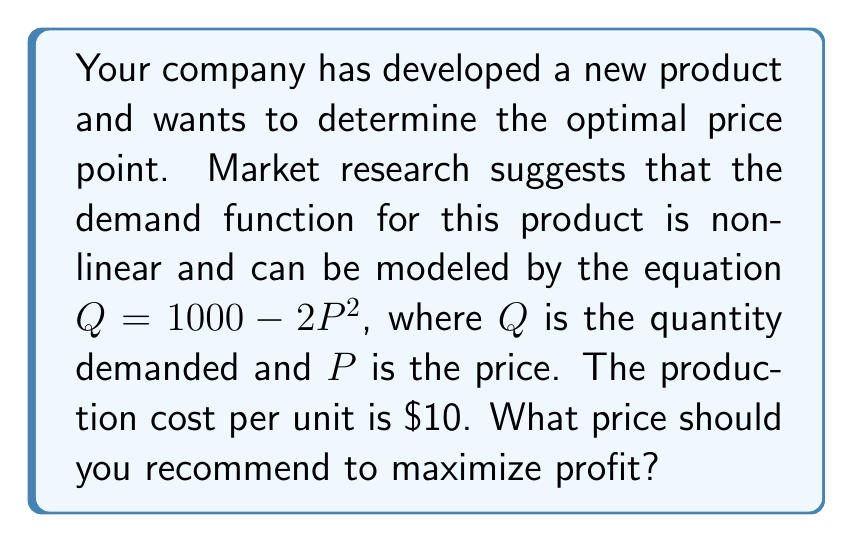Show me your answer to this math problem. To find the optimal price point, we need to follow these steps:

1. Define the profit function:
   Profit = Revenue - Cost
   $\pi = PQ - 10Q$

2. Substitute the demand function into the profit function:
   $\pi = P(1000 - 2P^2) - 10(1000 - 2P^2)$
   $\pi = 1000P - 2P^3 - 10000 + 20P^2$
   $\pi = -2P^3 + 20P^2 + 1000P - 10000$

3. To maximize profit, find the derivative of the profit function and set it equal to zero:
   $\frac{d\pi}{dP} = -6P^2 + 40P + 1000 = 0$

4. Solve the quadratic equation:
   $-6P^2 + 40P + 1000 = 0$
   $3P^2 - 20P - 500 = 0$
   
   Using the quadratic formula: $P = \frac{-b \pm \sqrt{b^2 - 4ac}}{2a}$
   
   $P = \frac{20 \pm \sqrt{400 + 6000}}{6} = \frac{20 \pm \sqrt{6400}}{6} = \frac{20 \pm 80}{6}$

5. This gives us two solutions:
   $P_1 = \frac{20 + 80}{6} = \frac{100}{6} \approx 16.67$
   $P_2 = \frac{20 - 80}{6} = -10$

6. Since price cannot be negative, we discard the second solution.

7. To confirm this is a maximum, check the second derivative:
   $\frac{d^2\pi}{dP^2} = -12P + 40$
   At $P = \frac{100}{6}$, $\frac{d^2\pi}{dP^2} = -12(\frac{100}{6}) + 40 = -160 < 0$

Therefore, the optimal price to maximize profit is $\frac{100}{6}$ or approximately $16.67.
Answer: $$\frac{100}{6}$$ (or approximately $16.67) 